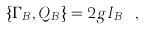<formula> <loc_0><loc_0><loc_500><loc_500>\{ \Gamma _ { B } , Q _ { B } \} = 2 g I _ { B } \ ,</formula> 